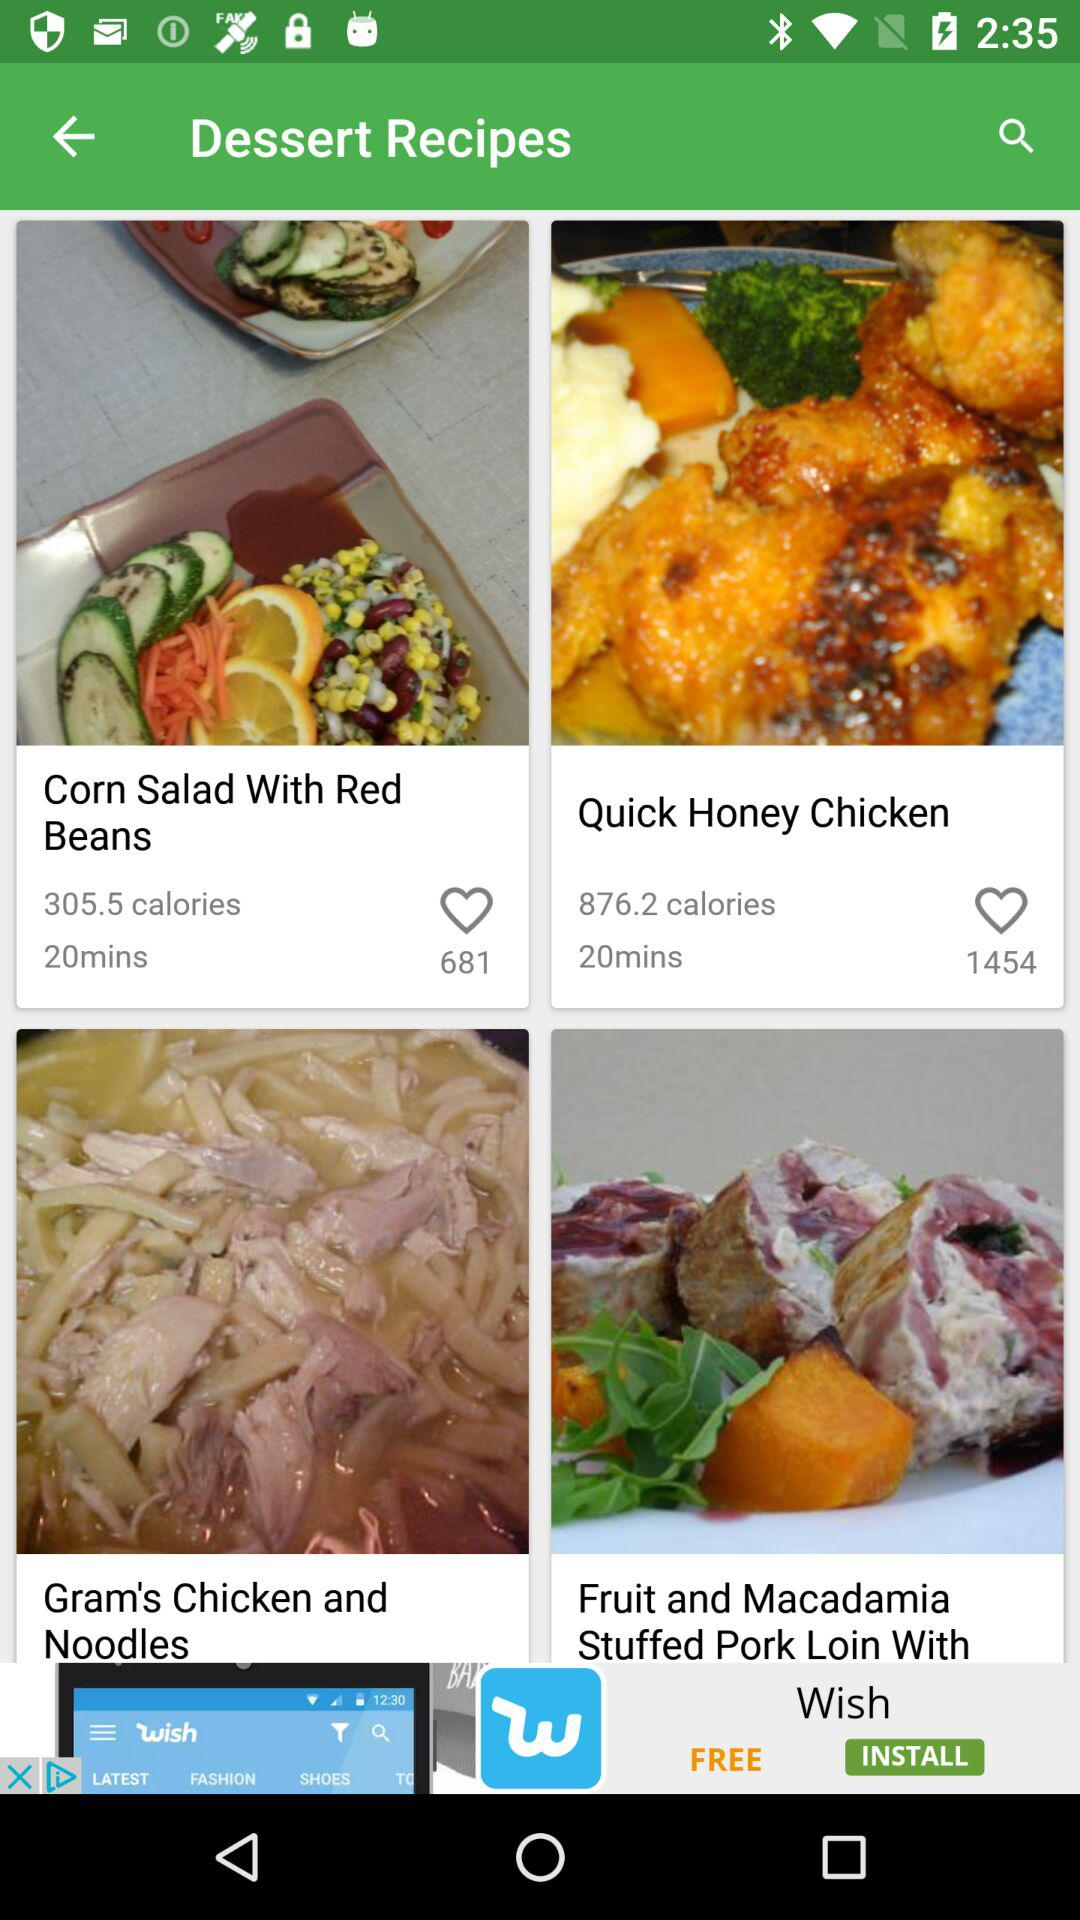How many calories are in "Com Salad With Red Beans"? The calories in "Com Salad With Red Beans" are 305.5. 